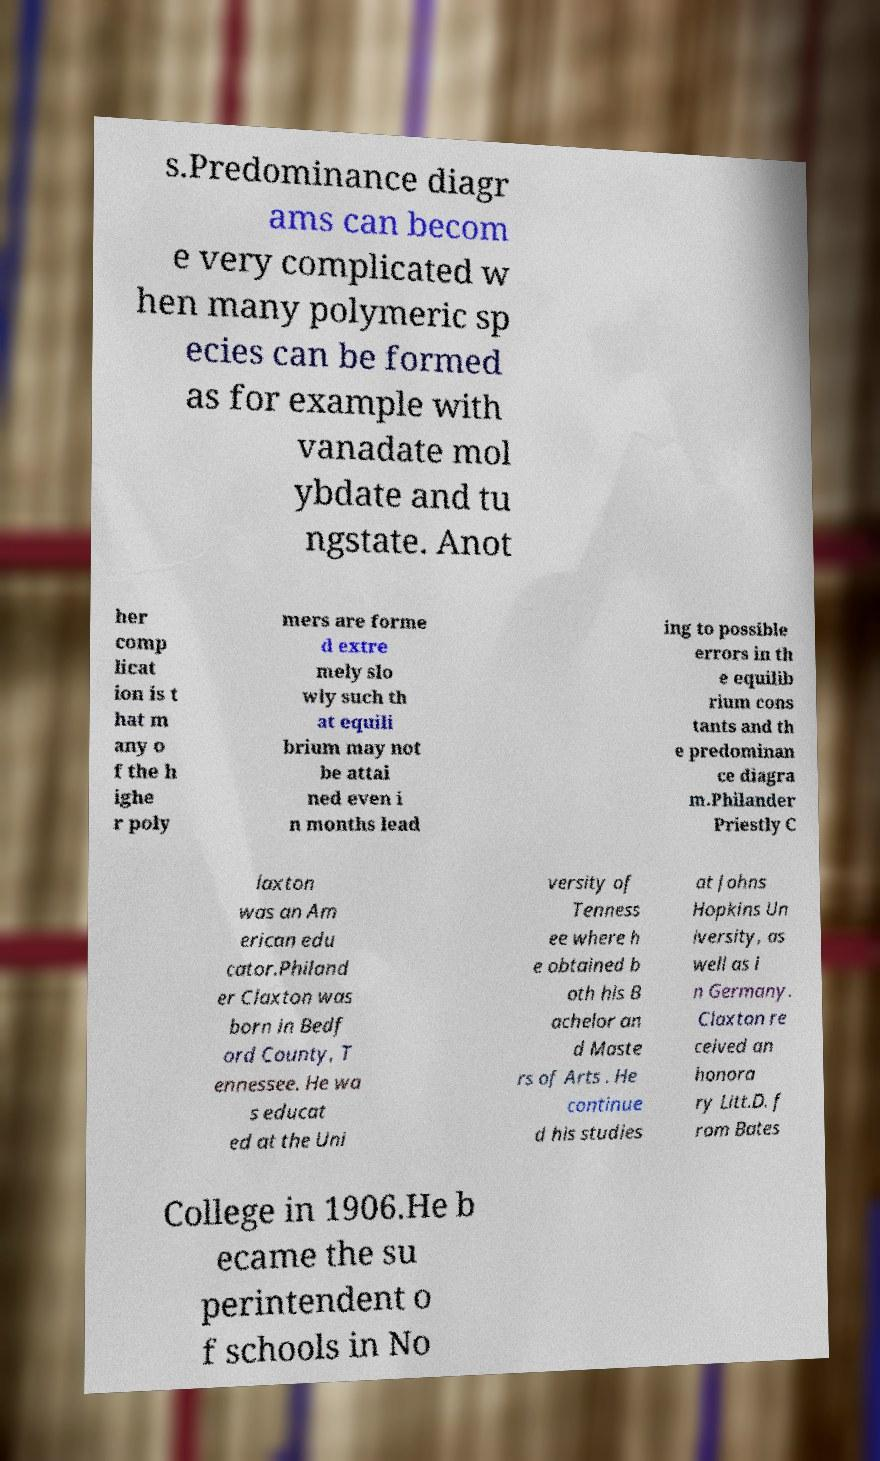Can you read and provide the text displayed in the image?This photo seems to have some interesting text. Can you extract and type it out for me? s.Predominance diagr ams can becom e very complicated w hen many polymeric sp ecies can be formed as for example with vanadate mol ybdate and tu ngstate. Anot her comp licat ion is t hat m any o f the h ighe r poly mers are forme d extre mely slo wly such th at equili brium may not be attai ned even i n months lead ing to possible errors in th e equilib rium cons tants and th e predominan ce diagra m.Philander Priestly C laxton was an Am erican edu cator.Philand er Claxton was born in Bedf ord County, T ennessee. He wa s educat ed at the Uni versity of Tenness ee where h e obtained b oth his B achelor an d Maste rs of Arts . He continue d his studies at Johns Hopkins Un iversity, as well as i n Germany. Claxton re ceived an honora ry Litt.D. f rom Bates College in 1906.He b ecame the su perintendent o f schools in No 